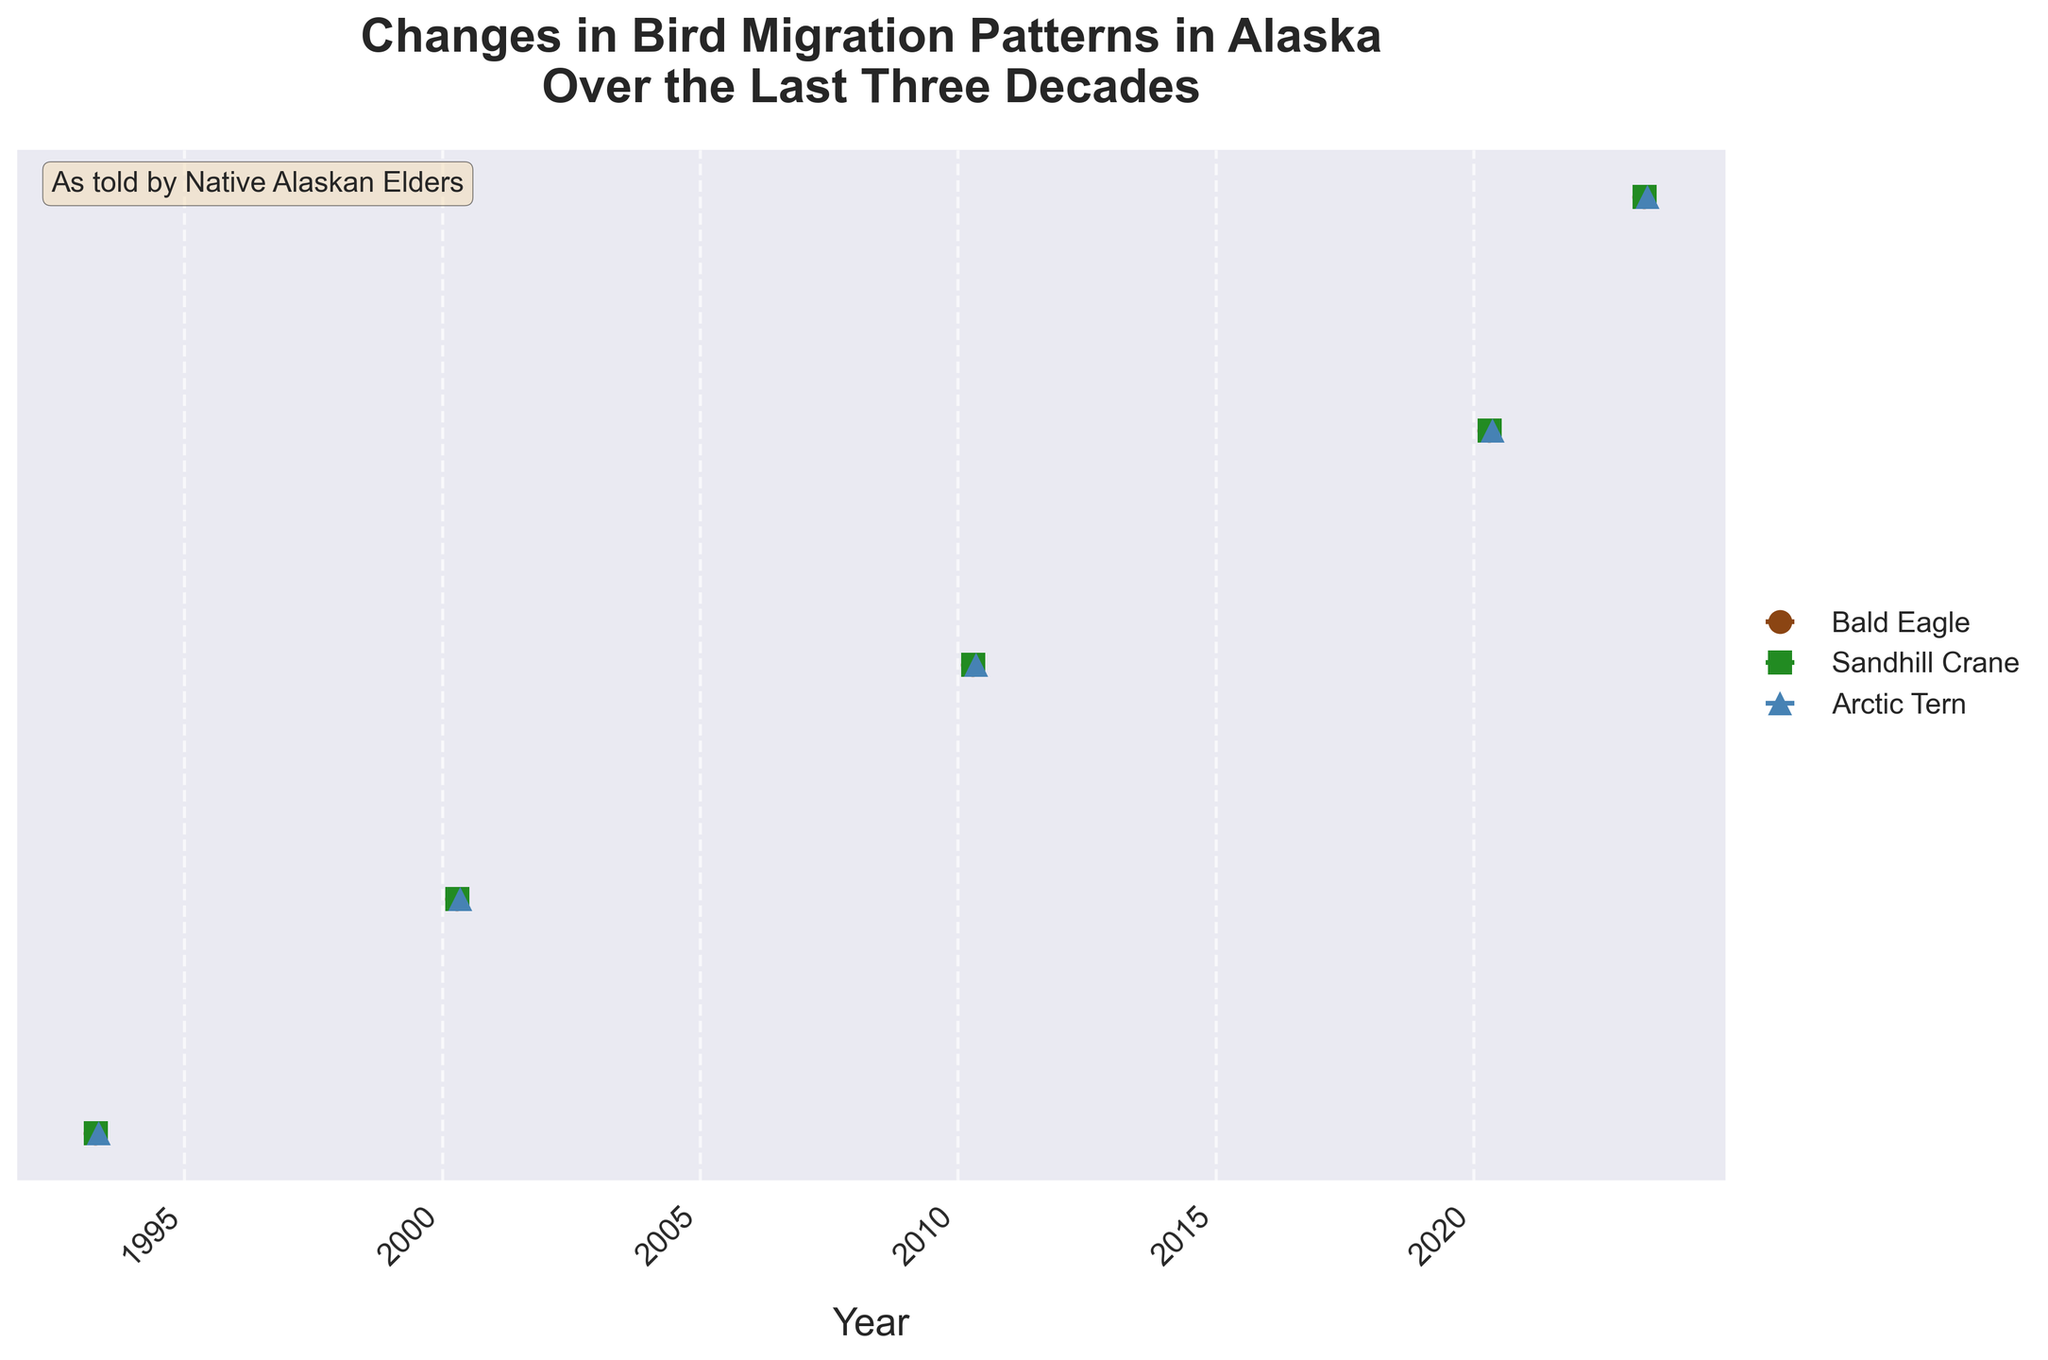What is the title of the figure? The title is usually displayed at the top of the figure. In this case, it’s clearly visible and can be read directly.
Answer: Changes in Bird Migration Patterns in Alaska Over the Last Three Decades How many different bird species are represented in the figure? The number of bird species can be determined by looking at the legend of the figure, which shows the different species represented by different markers and colors.
Answer: Three Which bird species has the latest average arrival date in 2023? By looking at the markers on the plot and matching them with the year 2023, we can see which one is the furthest to the right.
Answer: Arctic Tern Has the average arrival date of the Bald Eagle changed over the years? This can be observed by following the markers for the Bald Eagle from the left (earlier years) to the right (more recent years).
Answer: Yes What is the average arrival date of the Sandhill Crane in 2000? By locating the marker for Sandhill Crane in the year 2000, we can find the corresponding arrival date.
Answer: April 18 How has the arrival date of the Arctic Tern changed from 1993 to 2023? We compare the position of the markers for Arctic Tern in 1993 and 2023 to see the shift in dates.
Answer: It has shifted later Which species shows the most consistent pattern in arrival dates according to the error bars? The consistency can be evaluated by looking at the size of the error bars. Smaller error bars indicate more consistency.
Answer: Bald Eagle How does the standard deviation of arrival dates for Sandhill Crane in 2023 compare to that in 1993? By observing the length of the error bars for Sandhill Crane in both years, we can compare their sizes.
Answer: Larger in 2023 Which bird species' average arrival date has changed the most from 2010 to 2023? By comparing the shifts in arrival dates for all species between these years, we can identify which has the most noticeable change.
Answer: Arctic Tern On average, whose arrival dates are tending to get later over the years? We look at the overall trend of each bird species’ markers from left to right to determine if the trend is skewing later in the year.
Answer: All species 